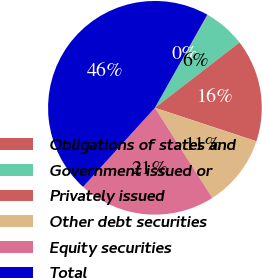Convert chart. <chart><loc_0><loc_0><loc_500><loc_500><pie_chart><fcel>Obligations of states and<fcel>Government issued or<fcel>Privately issued<fcel>Other debt securities<fcel>Equity securities<fcel>Total<nl><fcel>0.1%<fcel>6.28%<fcel>15.54%<fcel>10.91%<fcel>20.76%<fcel>46.41%<nl></chart> 